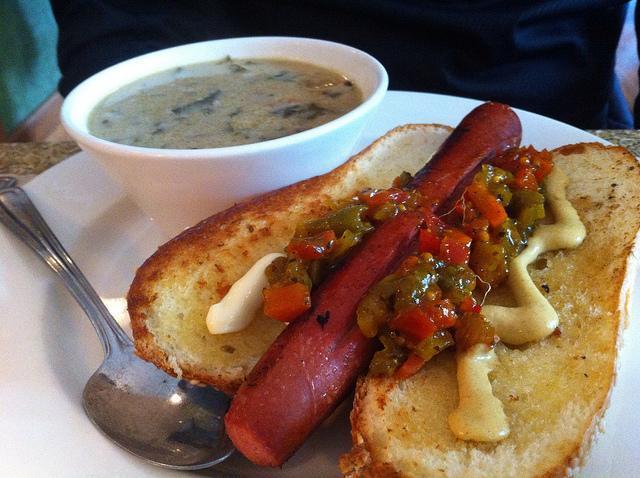Is the caption "The hot dog is far away from the person." a true representation of the image?
Answer yes or no. No. Is the statement "The bowl is touching the hot dog." accurate regarding the image?
Answer yes or no. Yes. 